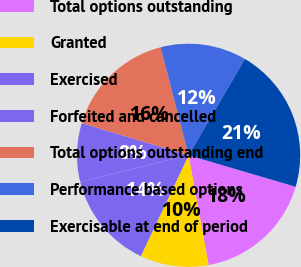<chart> <loc_0><loc_0><loc_500><loc_500><pie_chart><fcel>Total options outstanding<fcel>Granted<fcel>Exercised<fcel>Forfeited and cancelled<fcel>Total options outstanding end<fcel>Performance based options<fcel>Exercisable at end of period<nl><fcel>17.58%<fcel>9.91%<fcel>14.14%<fcel>8.48%<fcel>16.31%<fcel>12.46%<fcel>21.13%<nl></chart> 